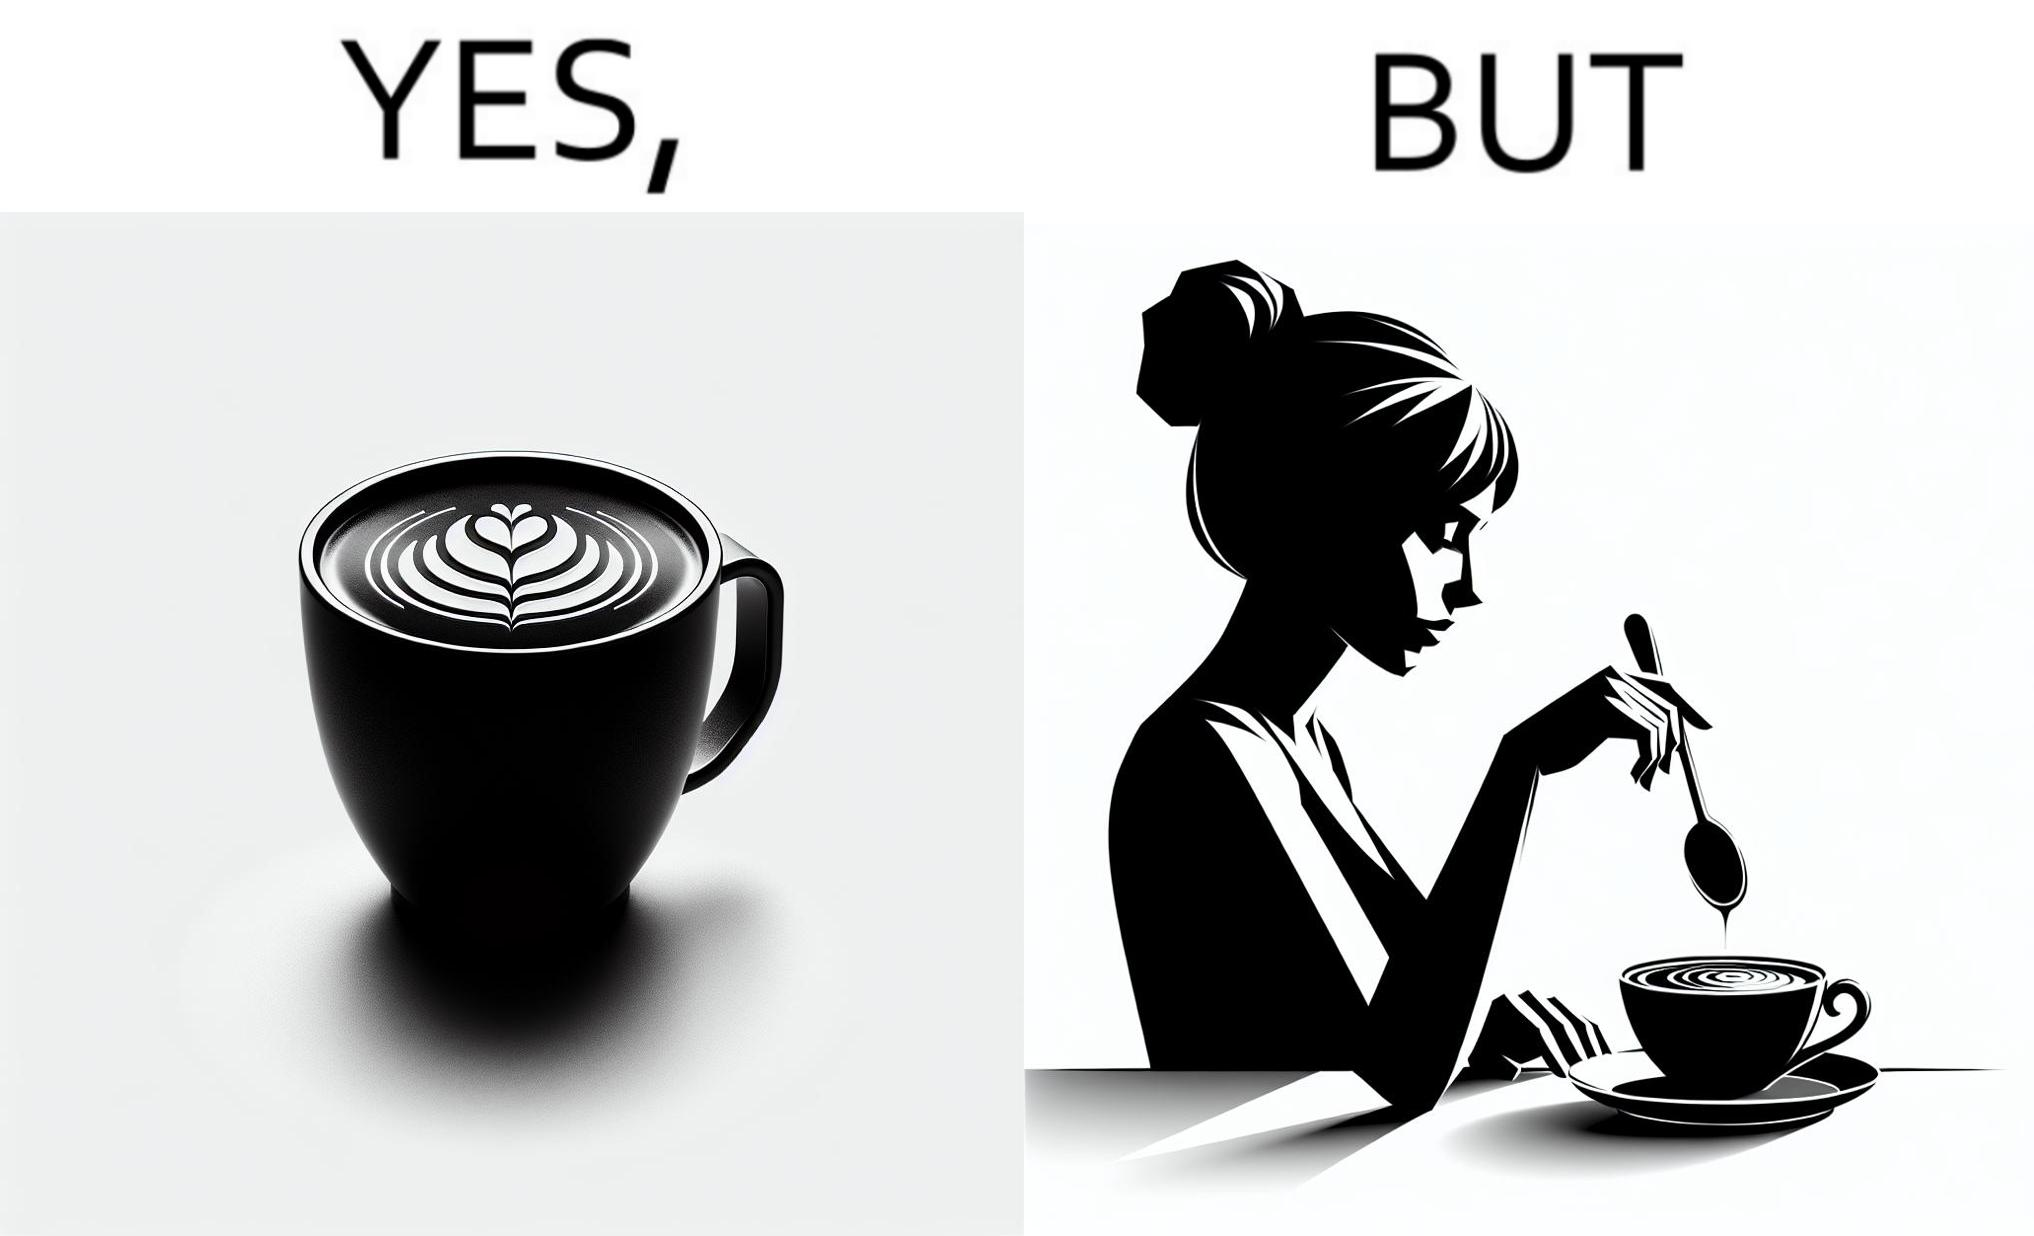Provide a description of this image. The image is ironic, because even when the coffee maker create latte art to make coffee look attractive but it is there just for a short time after that it is vanished 